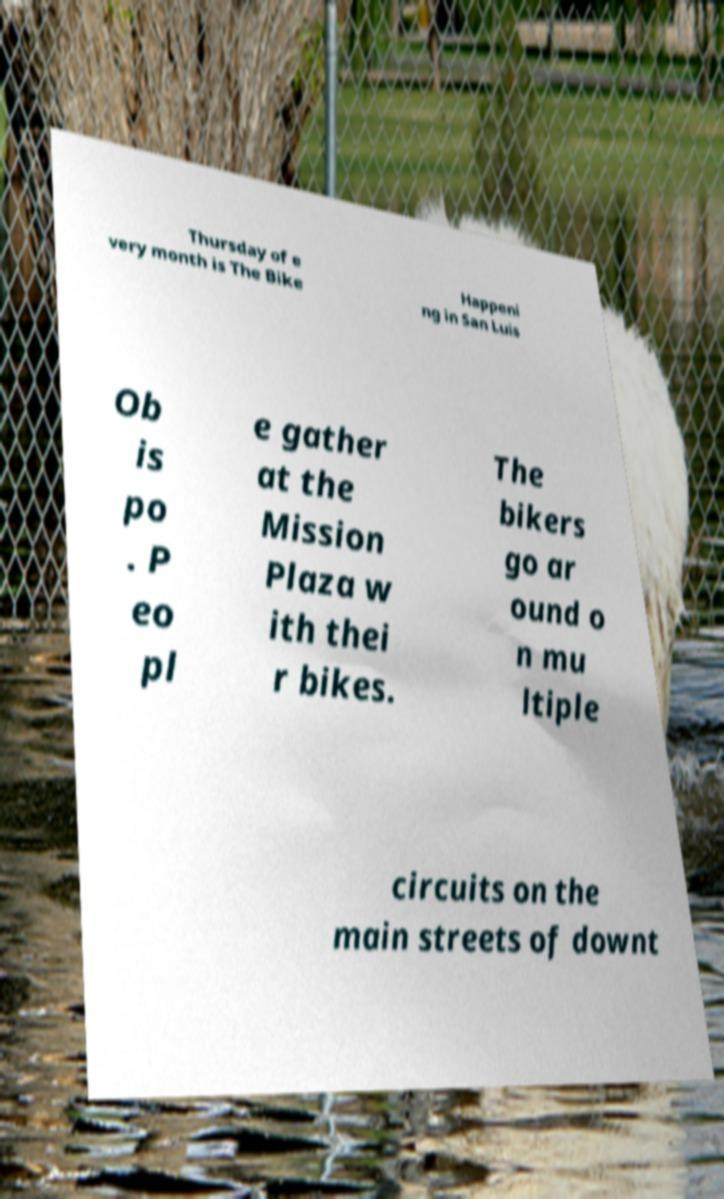Can you accurately transcribe the text from the provided image for me? Thursday of e very month is The Bike Happeni ng in San Luis Ob is po . P eo pl e gather at the Mission Plaza w ith thei r bikes. The bikers go ar ound o n mu ltiple circuits on the main streets of downt 